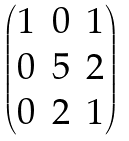<formula> <loc_0><loc_0><loc_500><loc_500>\begin{pmatrix} 1 & 0 & 1 \\ 0 & 5 & 2 \\ 0 & 2 & 1 \end{pmatrix}</formula> 